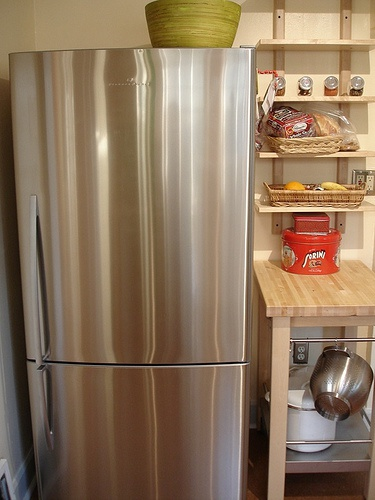Describe the objects in this image and their specific colors. I can see refrigerator in gray and maroon tones, bowl in gray, olive, and tan tones, bowl in gray, maroon, and black tones, banana in gray, tan, and khaki tones, and orange in gray, orange, red, and tan tones in this image. 